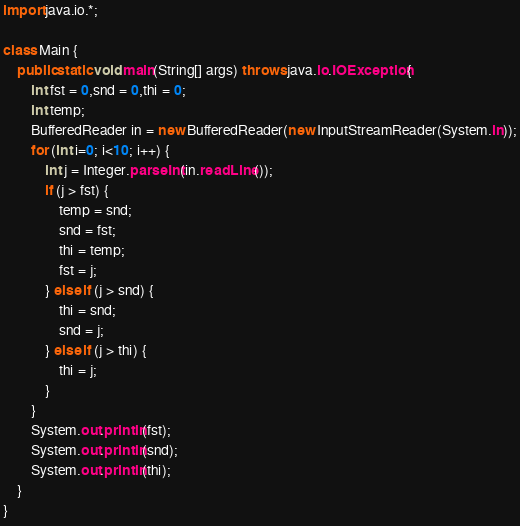Convert code to text. <code><loc_0><loc_0><loc_500><loc_500><_Java_>import java.io.*;

class Main {
    public static void main(String[] args) throws java.io.IOException{
        int fst = 0,snd = 0,thi = 0;
        int temp;
        BufferedReader in = new BufferedReader(new InputStreamReader(System.in));
        for (int i=0; i<10; i++) {
            int j = Integer.parseInt(in.readLine());
            if (j > fst) {
                temp = snd;
                snd = fst;
                thi = temp;
                fst = j;
            } else if (j > snd) {
                thi = snd;
                snd = j;
            } else if (j > thi) {
                thi = j;
            }
        }
        System.out.println(fst);
        System.out.println(snd);
        System.out.println(thi);
    }
}</code> 